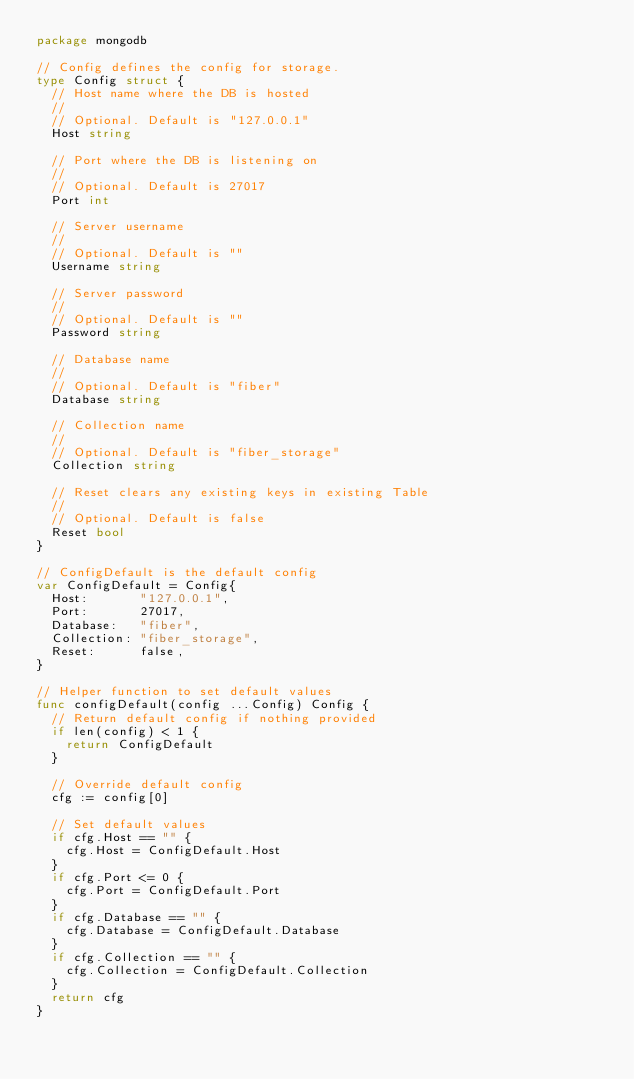Convert code to text. <code><loc_0><loc_0><loc_500><loc_500><_Go_>package mongodb

// Config defines the config for storage.
type Config struct {
	// Host name where the DB is hosted
	//
	// Optional. Default is "127.0.0.1"
	Host string

	// Port where the DB is listening on
	//
	// Optional. Default is 27017
	Port int

	// Server username
	//
	// Optional. Default is ""
	Username string

	// Server password
	//
	// Optional. Default is ""
	Password string

	// Database name
	//
	// Optional. Default is "fiber"
	Database string

	// Collection name
	//
	// Optional. Default is "fiber_storage"
	Collection string

	// Reset clears any existing keys in existing Table
	//
	// Optional. Default is false
	Reset bool
}

// ConfigDefault is the default config
var ConfigDefault = Config{
	Host:       "127.0.0.1",
	Port:       27017,
	Database:   "fiber",
	Collection: "fiber_storage",
	Reset:      false,
}

// Helper function to set default values
func configDefault(config ...Config) Config {
	// Return default config if nothing provided
	if len(config) < 1 {
		return ConfigDefault
	}

	// Override default config
	cfg := config[0]

	// Set default values
	if cfg.Host == "" {
		cfg.Host = ConfigDefault.Host
	}
	if cfg.Port <= 0 {
		cfg.Port = ConfigDefault.Port
	}
	if cfg.Database == "" {
		cfg.Database = ConfigDefault.Database
	}
	if cfg.Collection == "" {
		cfg.Collection = ConfigDefault.Collection
	}
	return cfg
}
</code> 